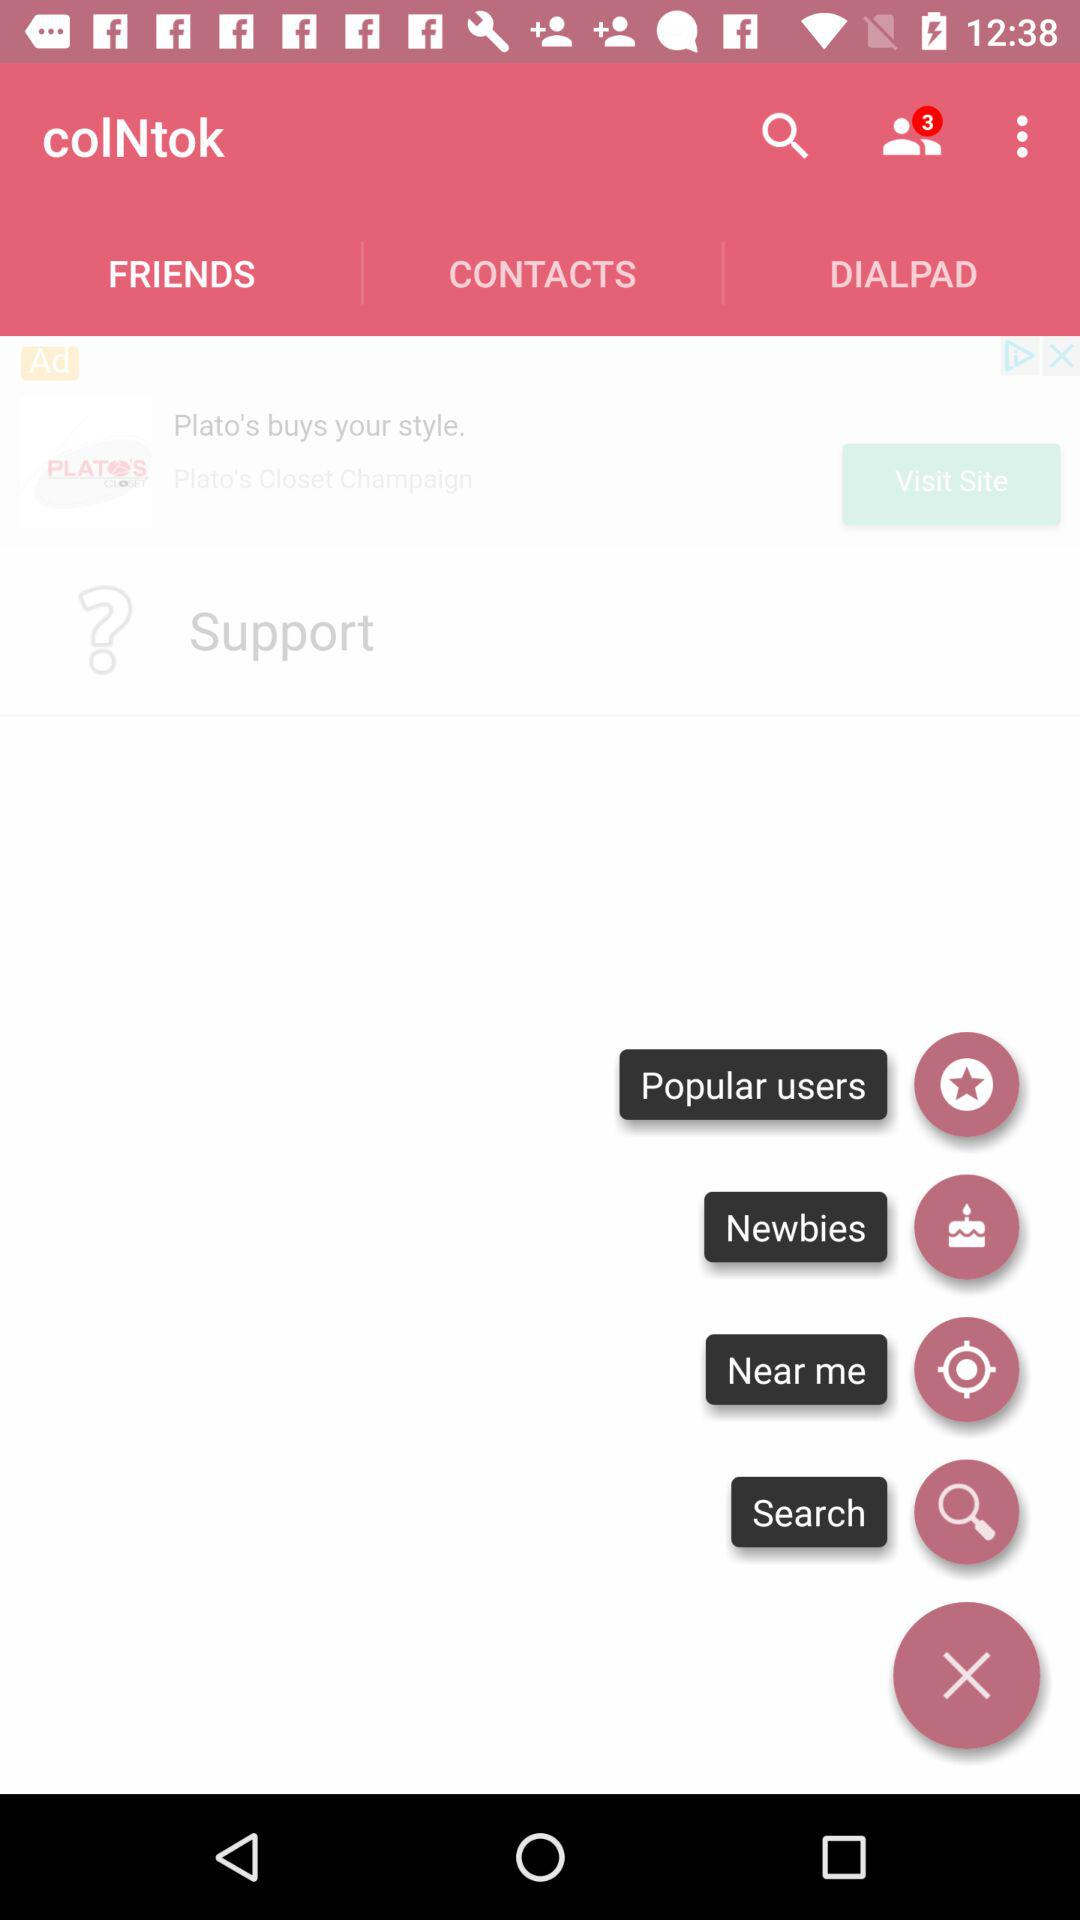What is the application name? The application name is "colNtok". 